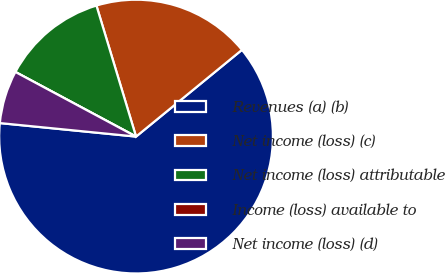<chart> <loc_0><loc_0><loc_500><loc_500><pie_chart><fcel>Revenues (a) (b)<fcel>Net income (loss) (c)<fcel>Net income (loss) attributable<fcel>Income (loss) available to<fcel>Net income (loss) (d)<nl><fcel>62.49%<fcel>18.75%<fcel>12.5%<fcel>0.0%<fcel>6.25%<nl></chart> 